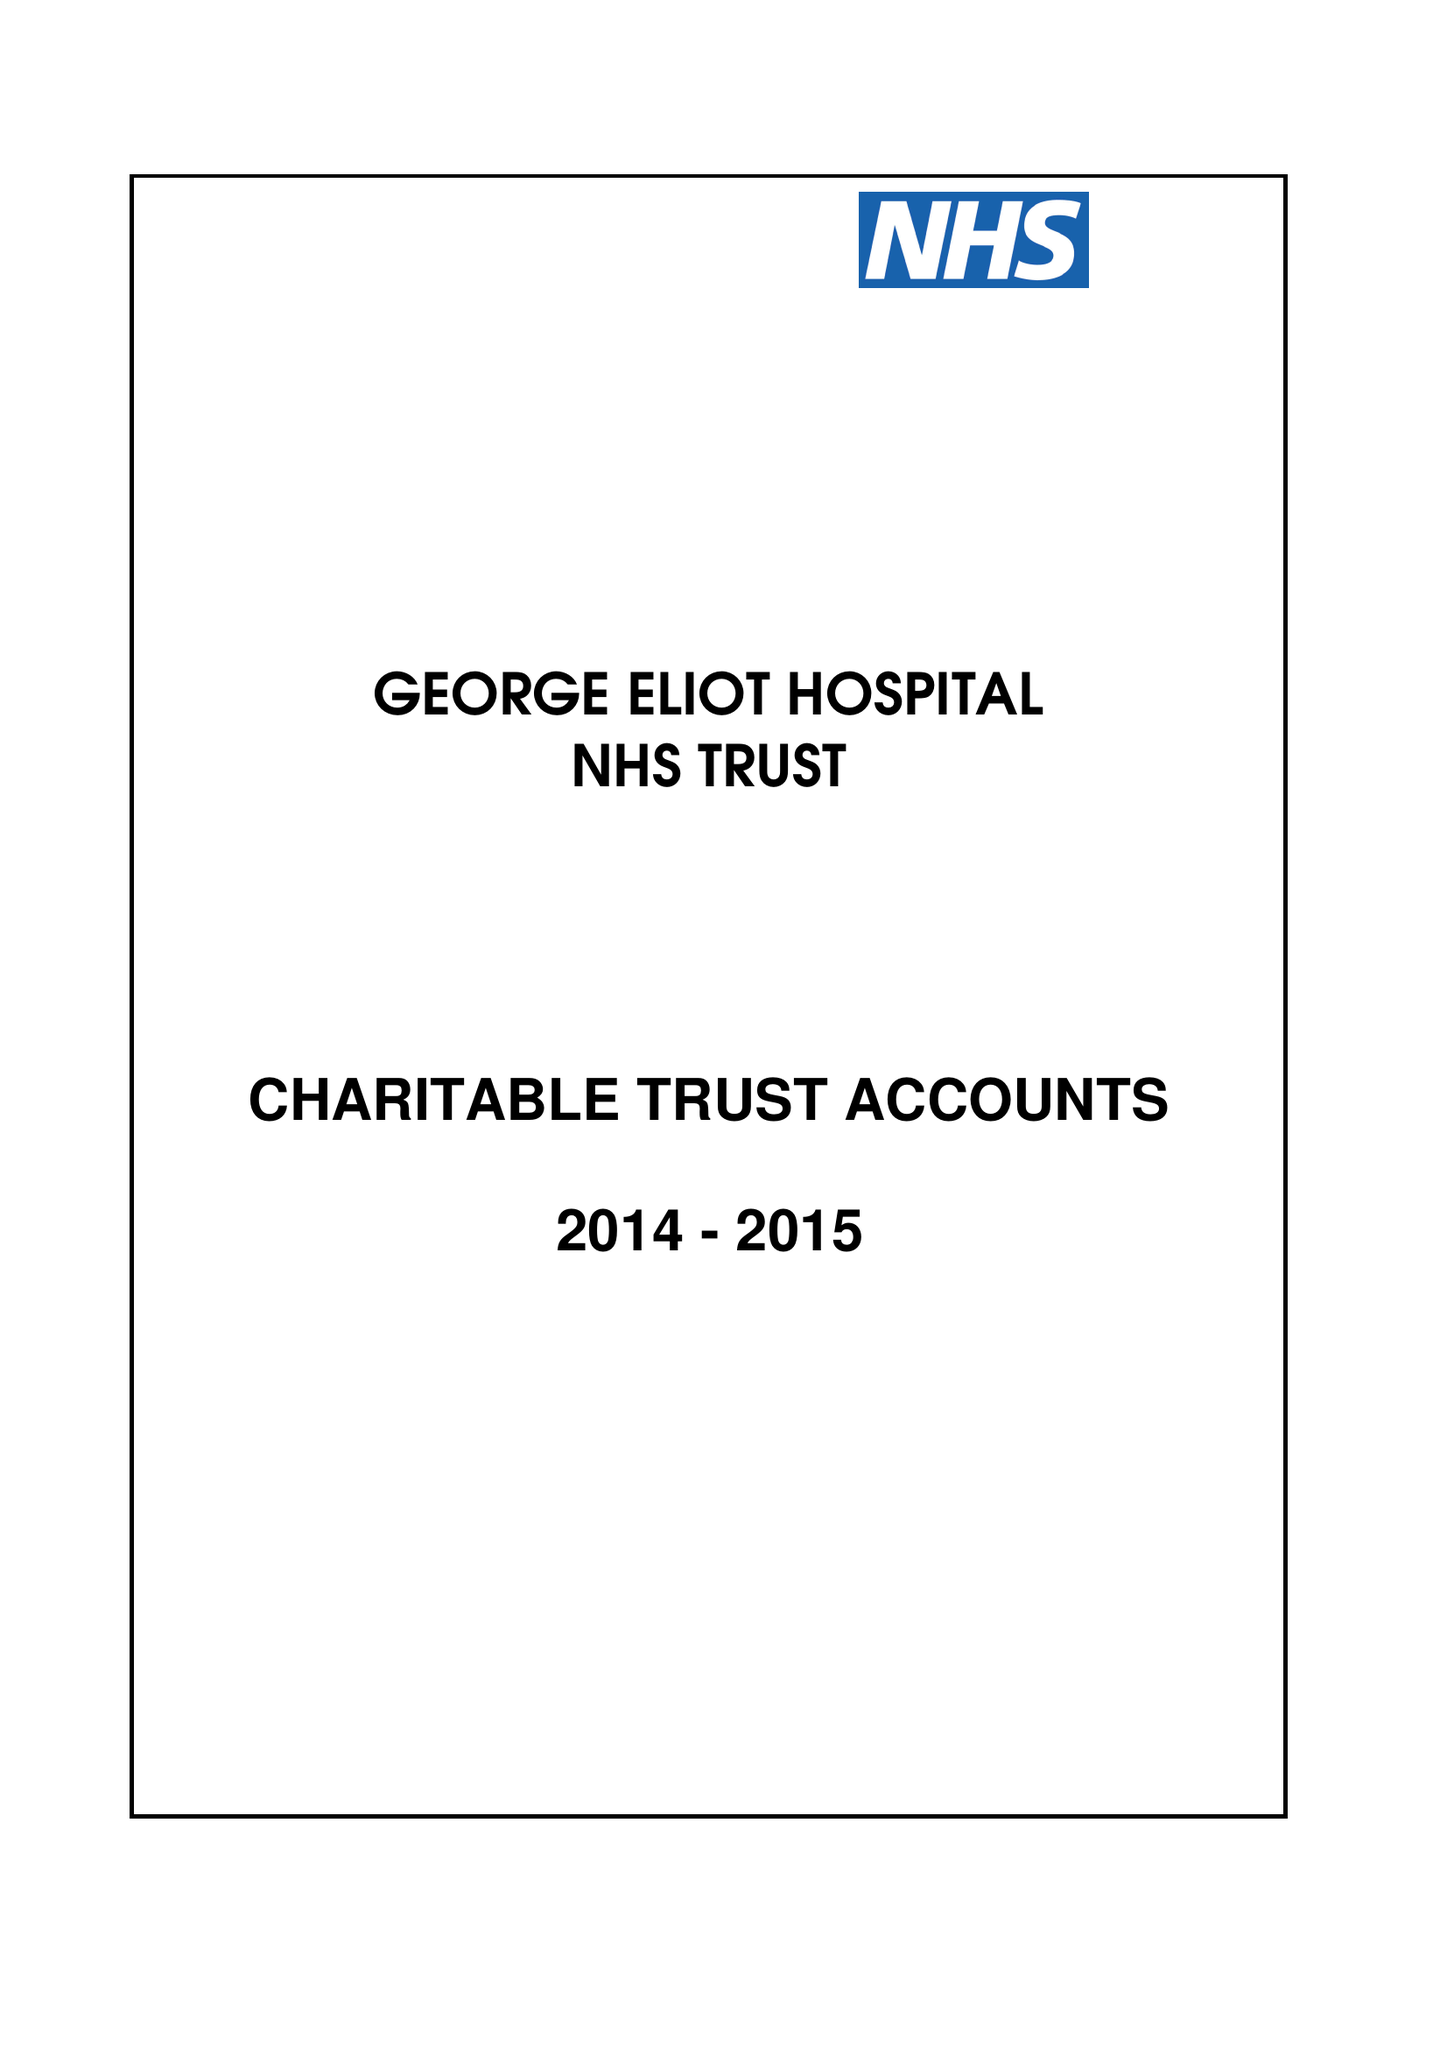What is the value for the spending_annually_in_british_pounds?
Answer the question using a single word or phrase. 185000.00 